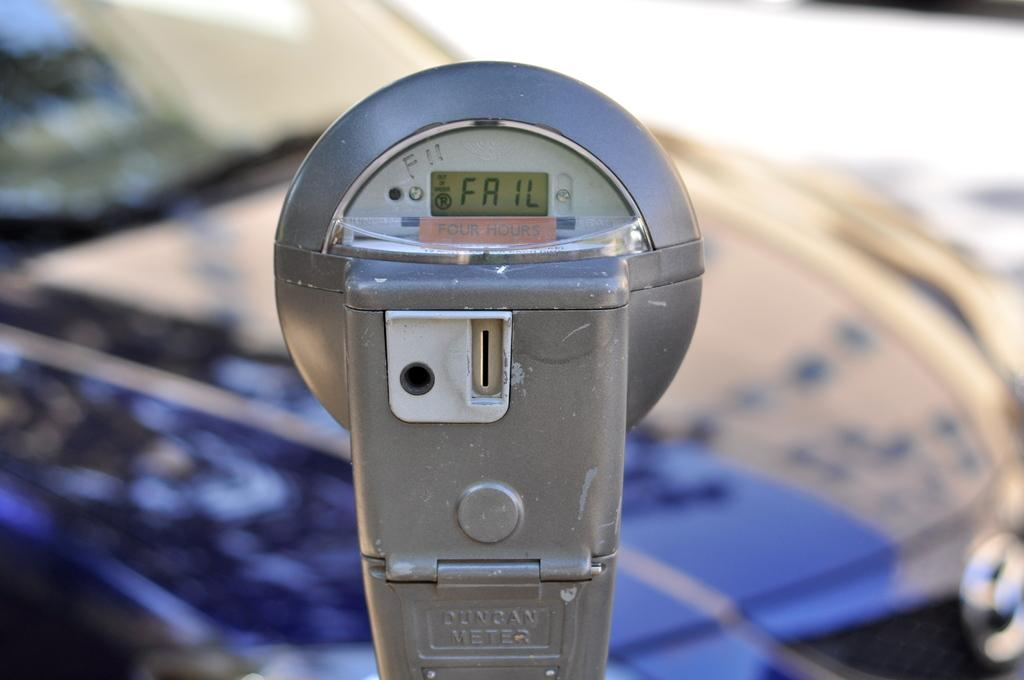Provide a one-sentence caption for the provided image. A parking meter displays a fail message on a sunny day. 